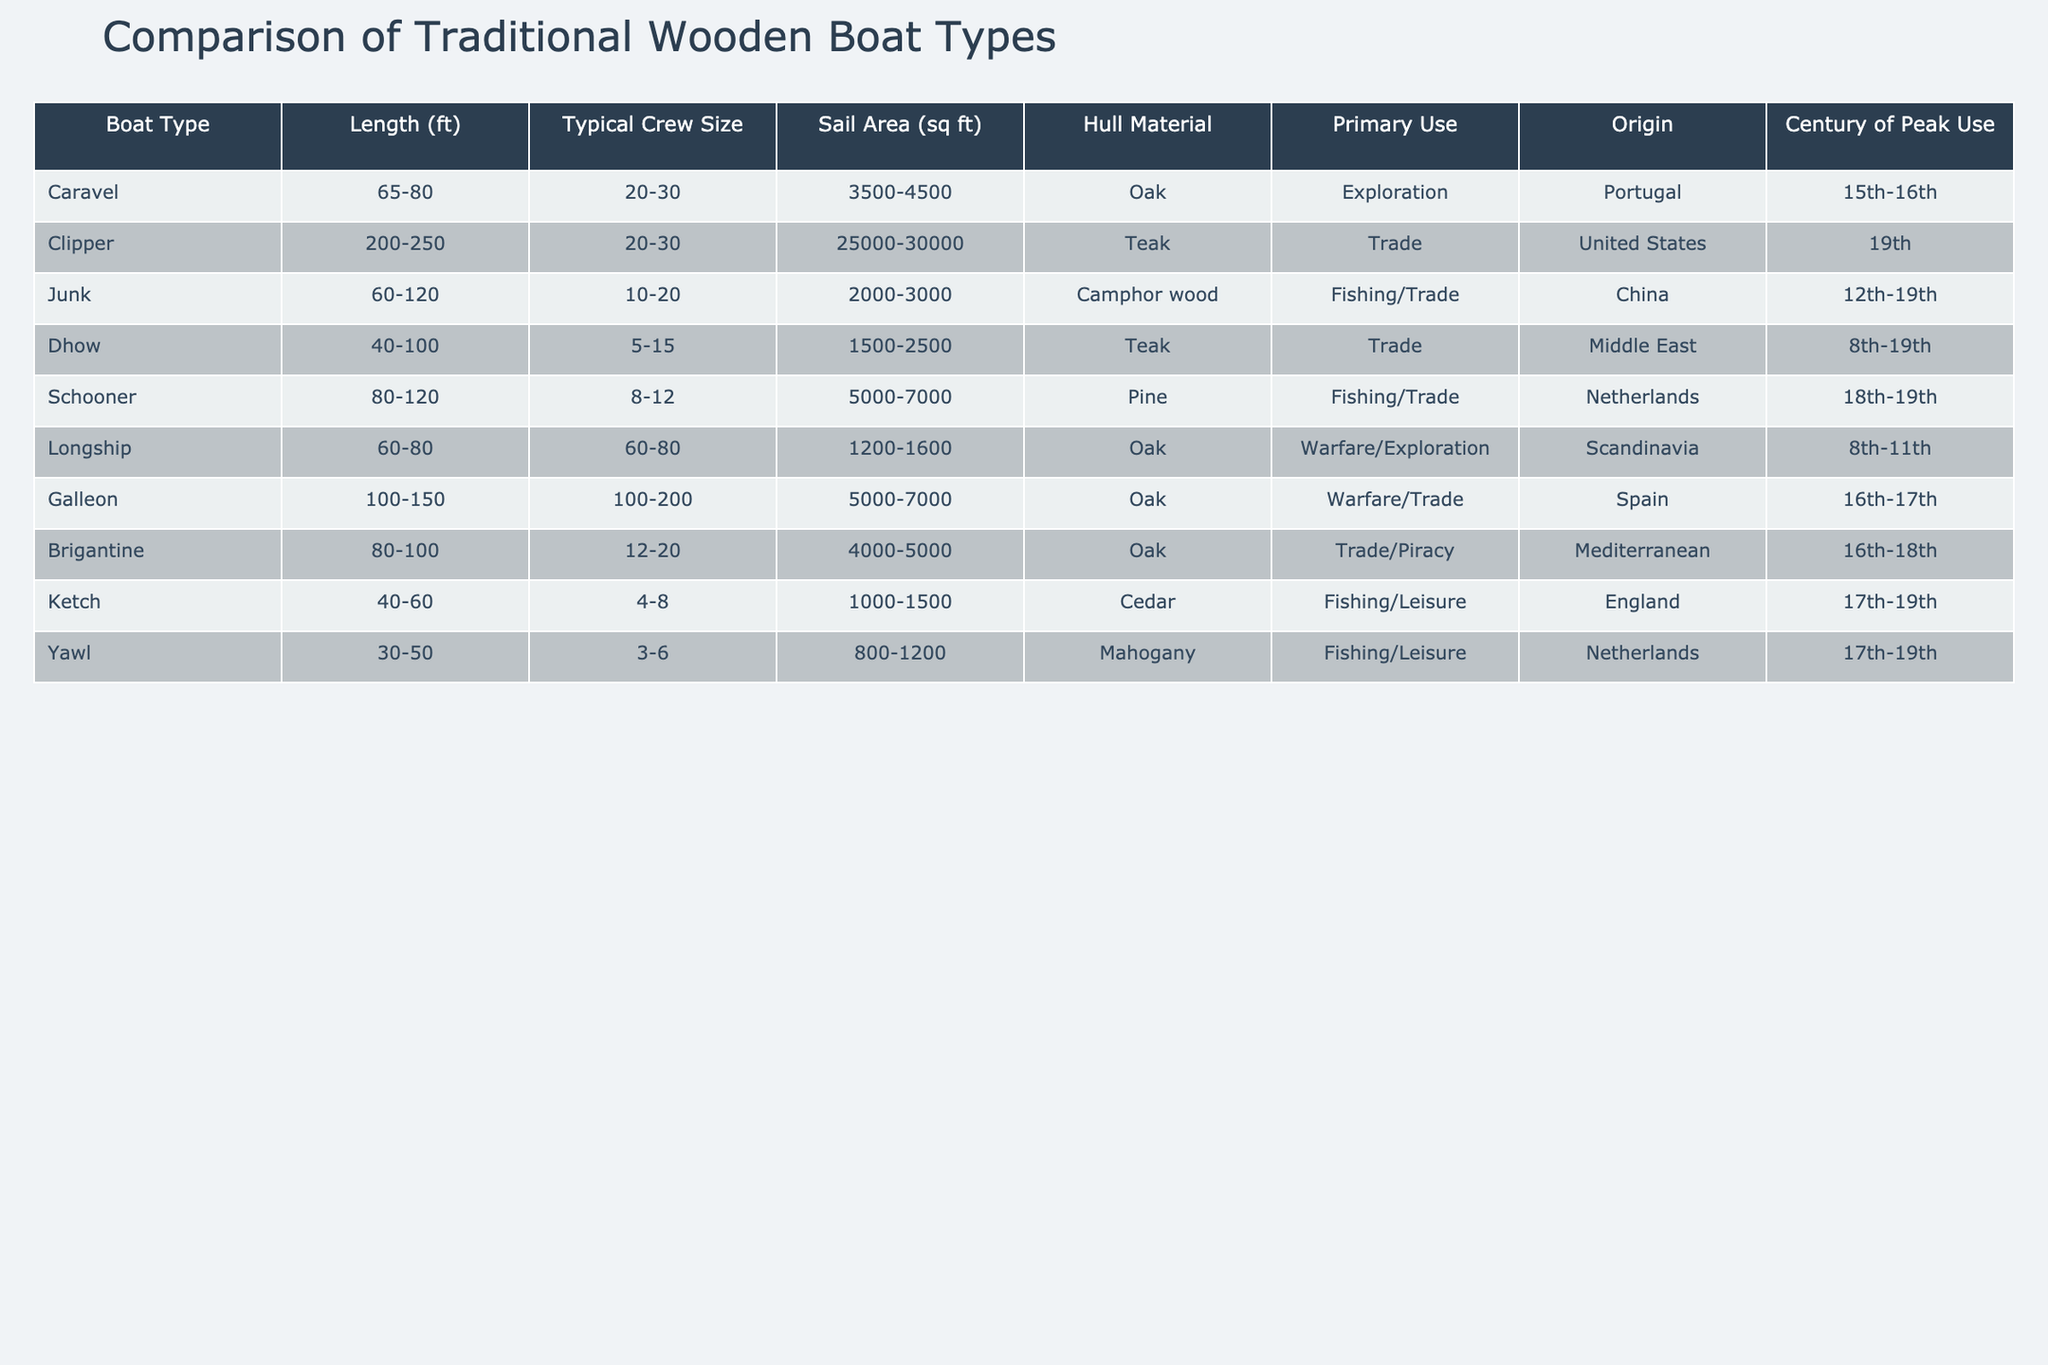What is the typical crew size of a Clipper? The Clipper, as presented in the table, has a typical crew size listed as 20-30.
Answer: 20-30 Which boat type has the largest sail area? The Clipper has the largest sail area of 25000-30000 sq ft according to the table.
Answer: Clipper How many boat types are primarily used for fishing? In the table, the Junk, Schooner, Ketch, and Yawl are all used for fishing, totaling four boat types.
Answer: 4 Is the Dhow primarily used for warfare? The Dhow's primary use, according to the table, is for trade, not warfare; hence this statement is false.
Answer: False What is the average length of the Longship and the Ketch combined? The Longship's length is 60-80 ft and the Ketch's length is 40-60 ft. Taking an average length of 70 ft for the Longship and 50 ft for the Ketch, the combined average length is (70 + 50) / 2 = 60 ft.
Answer: 60 ft Which boat type has its peak use in the 19th century? According to the table, the Clipper and the Schooner have their peak use in the 19th century, confirming there are two such boat types.
Answer: 2 What is the difference in typical crew size between the Galleon and the Junk? The Galleon has a typical crew size of 100-200 while the Junk has 10-20. The difference in the low end is 100 - 10 = 90 and the high end is 200 - 20 = 180.
Answer: 90-180 Which boat types are made from oak? The Caravel, Galleon, Brigantine, and Longship are identified in the table as being made from oak.
Answer: 4 What is the primary use of the Yawl? The table indicates that the primary use of the Yawl is for fishing/leisure.
Answer: Fishing/Leisure How does the typical crew size of the Schooner compare with that of the Dhow? The Schooner's typical crew size is 8-12 while the Dhow's is 5-15. The Schooner has a higher minimum of 8 compared to Dhow's 5; thus, on average, the Schooner generally requires more crew.
Answer: Schooner has a higher minimum crew size 